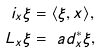<formula> <loc_0><loc_0><loc_500><loc_500>i _ { x } \xi & = \langle \xi , x \rangle , \\ L _ { x } \xi & = \ a d _ { x } ^ { * } \xi ,</formula> 